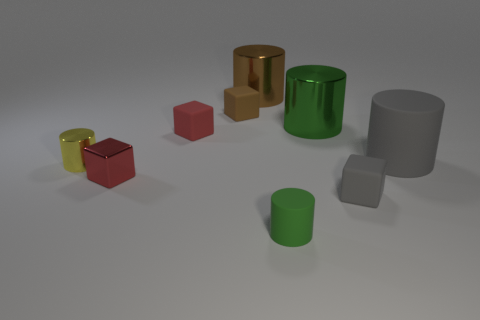Is the color of the tiny rubber cylinder the same as the tiny metal cylinder?
Make the answer very short. No. What number of balls are matte things or small blue objects?
Give a very brief answer. 0. There is a cylinder that is both to the right of the small yellow object and in front of the gray cylinder; what is its material?
Your answer should be very brief. Rubber. There is a tiny gray rubber cube; how many small red metallic things are right of it?
Provide a short and direct response. 0. Do the tiny red block that is behind the small yellow metallic cylinder and the small cylinder in front of the red metal thing have the same material?
Ensure brevity in your answer.  Yes. How many things are either metallic things that are to the left of the small metallic block or large cylinders?
Your response must be concise. 4. Is the number of big gray things behind the red rubber block less than the number of large gray rubber things that are in front of the large brown cylinder?
Provide a succinct answer. Yes. What number of other objects are there of the same size as the red matte thing?
Provide a short and direct response. 5. Does the brown cylinder have the same material as the object that is left of the red shiny cube?
Your answer should be compact. Yes. What number of objects are either tiny cylinders that are to the right of the brown matte cube or metal objects to the left of the tiny green rubber object?
Make the answer very short. 4. 